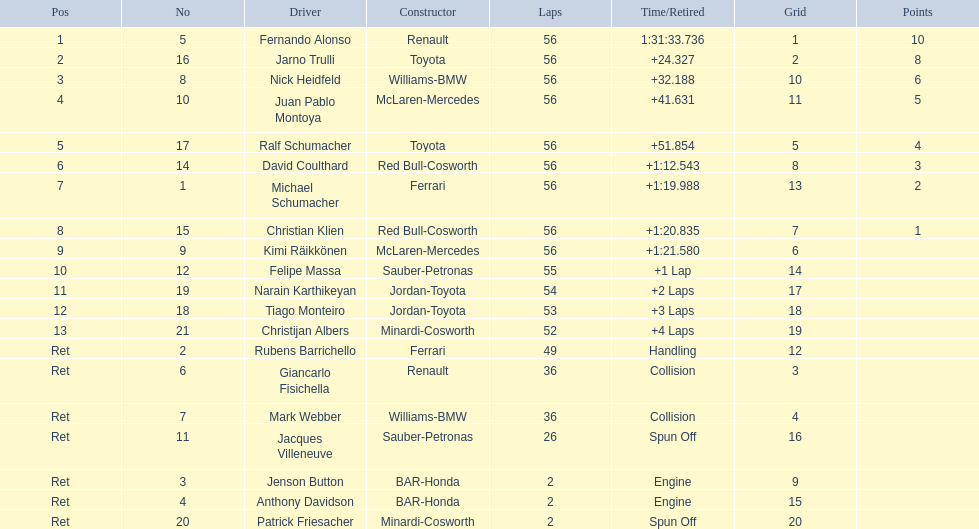What driver finished first? Fernando Alonso. 